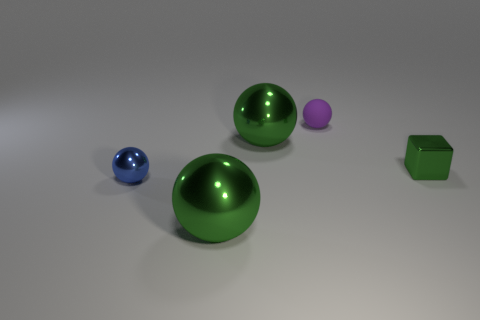What color is the tiny metallic object that is left of the purple rubber ball behind the big metallic ball in front of the tiny blue metallic ball?
Your answer should be compact. Blue. What number of green metallic things are the same size as the purple matte thing?
Your response must be concise. 1. The small thing that is behind the tiny green cube is what color?
Make the answer very short. Purple. What number of other objects are there of the same size as the green cube?
Your answer should be compact. 2. Is the color of the block the same as the big shiny object behind the small green thing?
Keep it short and to the point. Yes. Are there any tiny purple objects of the same shape as the tiny blue metallic object?
Make the answer very short. Yes. What number of objects are either green metal spheres or things to the right of the tiny rubber ball?
Provide a short and direct response. 3. How many other things are there of the same material as the small block?
Your answer should be compact. 3. What number of things are either large objects or blue metal spheres?
Provide a succinct answer. 3. Is the number of blue shiny objects that are to the left of the purple object greater than the number of tiny metal balls that are right of the small green metallic block?
Your response must be concise. Yes. 